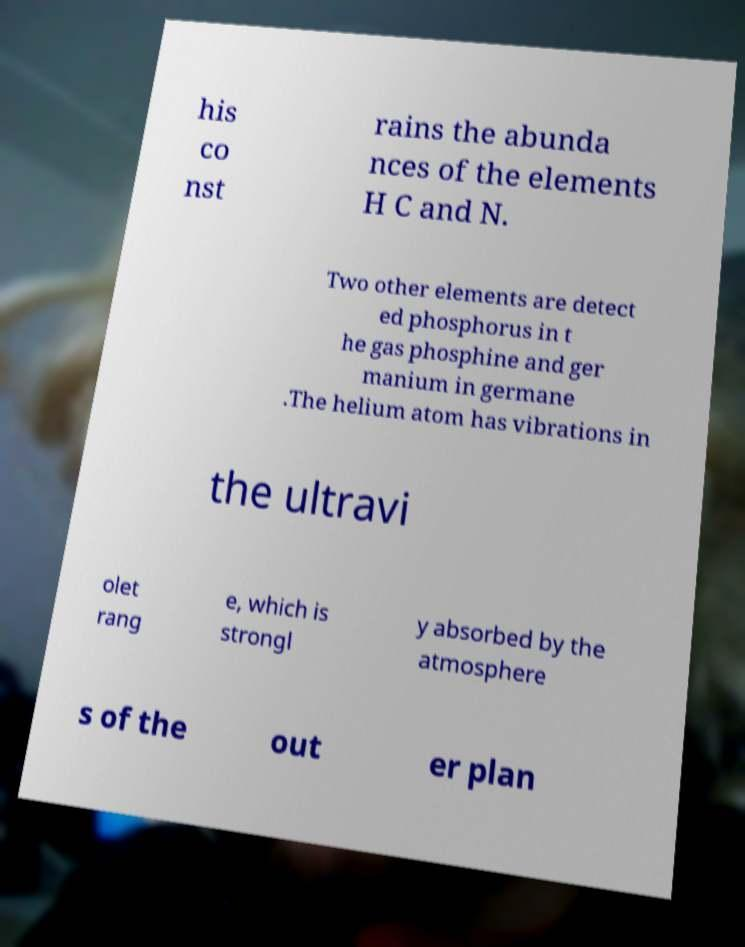Could you assist in decoding the text presented in this image and type it out clearly? his co nst rains the abunda nces of the elements H C and N. Two other elements are detect ed phosphorus in t he gas phosphine and ger manium in germane .The helium atom has vibrations in the ultravi olet rang e, which is strongl y absorbed by the atmosphere s of the out er plan 